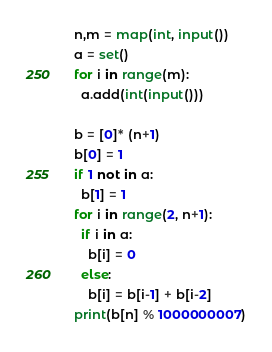<code> <loc_0><loc_0><loc_500><loc_500><_Python_>n,m = map(int, input())
a = set()
for i in range(m):
  a.add(int(input()))
  
b = [0]* (n+1)
b[0] = 1
if 1 not in a:
  b[1] = 1
for i in range(2, n+1):
  if i in a:
    b[i] = 0
  else:
    b[i] = b[i-1] + b[i-2]
print(b[n] % 1000000007)</code> 